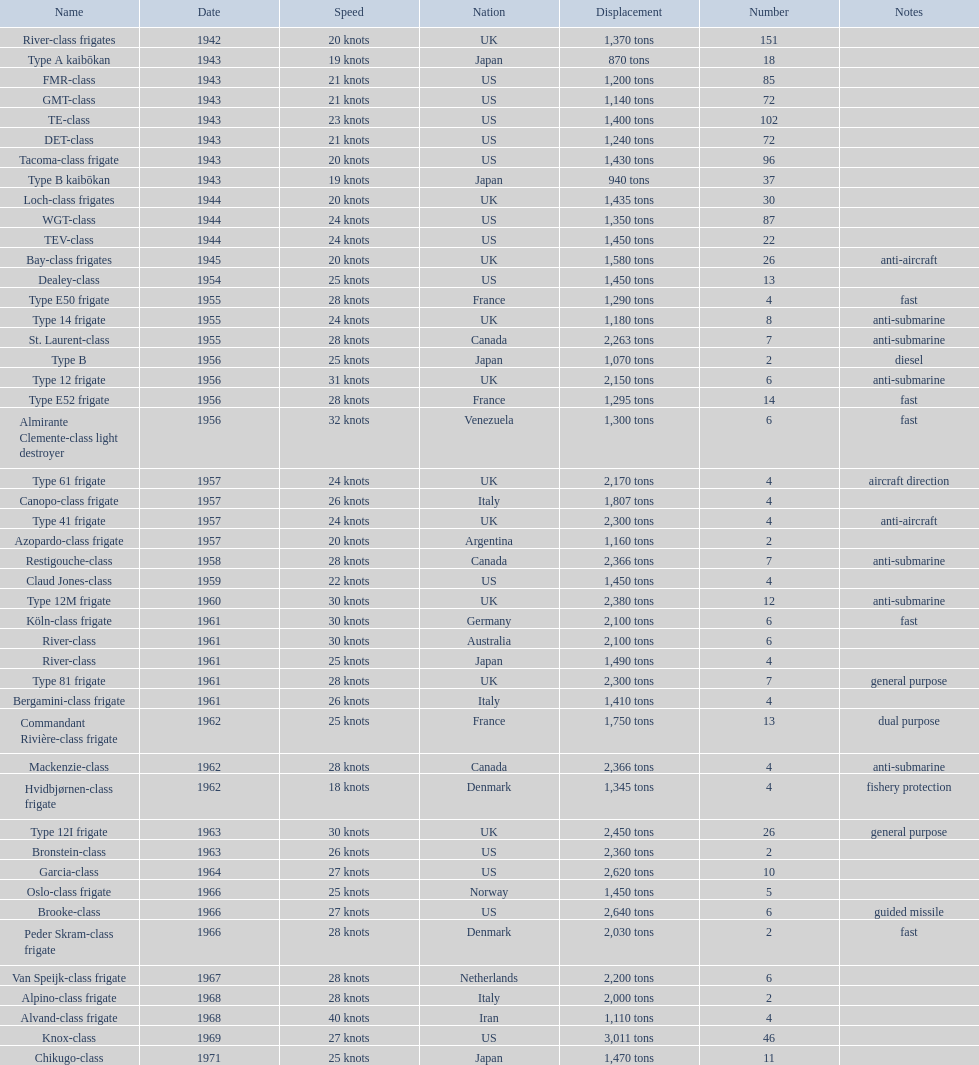What is the difference in speed for the gmt-class and the te-class? 2 knots. 